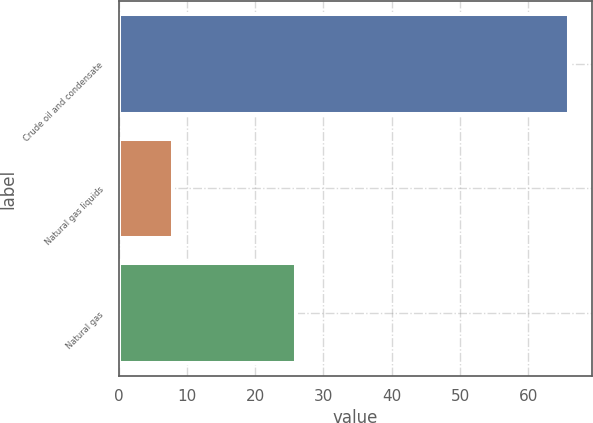<chart> <loc_0><loc_0><loc_500><loc_500><bar_chart><fcel>Crude oil and condensate<fcel>Natural gas liquids<fcel>Natural gas<nl><fcel>66<fcel>8<fcel>26<nl></chart> 